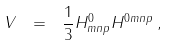Convert formula to latex. <formula><loc_0><loc_0><loc_500><loc_500>V \ = \ \frac { 1 } { 3 } H ^ { 0 } _ { m n p } H ^ { 0 m n p } \, ,</formula> 